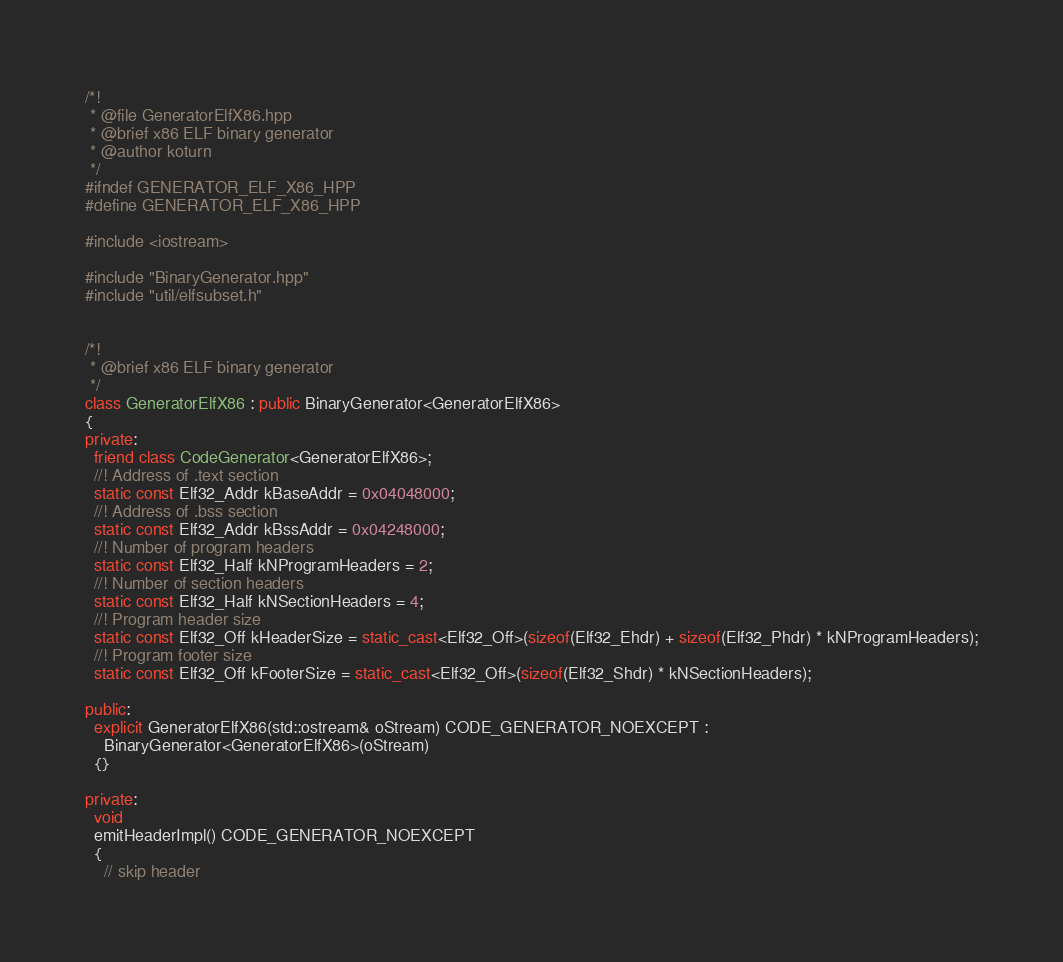Convert code to text. <code><loc_0><loc_0><loc_500><loc_500><_C++_>/*!
 * @file GeneratorElfX86.hpp
 * @brief x86 ELF binary generator
 * @author koturn
 */
#ifndef GENERATOR_ELF_X86_HPP
#define GENERATOR_ELF_X86_HPP

#include <iostream>

#include "BinaryGenerator.hpp"
#include "util/elfsubset.h"


/*!
 * @brief x86 ELF binary generator
 */
class GeneratorElfX86 : public BinaryGenerator<GeneratorElfX86>
{
private:
  friend class CodeGenerator<GeneratorElfX86>;
  //! Address of .text section
  static const Elf32_Addr kBaseAddr = 0x04048000;
  //! Address of .bss section
  static const Elf32_Addr kBssAddr = 0x04248000;
  //! Number of program headers
  static const Elf32_Half kNProgramHeaders = 2;
  //! Number of section headers
  static const Elf32_Half kNSectionHeaders = 4;
  //! Program header size
  static const Elf32_Off kHeaderSize = static_cast<Elf32_Off>(sizeof(Elf32_Ehdr) + sizeof(Elf32_Phdr) * kNProgramHeaders);
  //! Program footer size
  static const Elf32_Off kFooterSize = static_cast<Elf32_Off>(sizeof(Elf32_Shdr) * kNSectionHeaders);

public:
  explicit GeneratorElfX86(std::ostream& oStream) CODE_GENERATOR_NOEXCEPT :
    BinaryGenerator<GeneratorElfX86>(oStream)
  {}

private:
  void
  emitHeaderImpl() CODE_GENERATOR_NOEXCEPT
  {
    // skip header</code> 